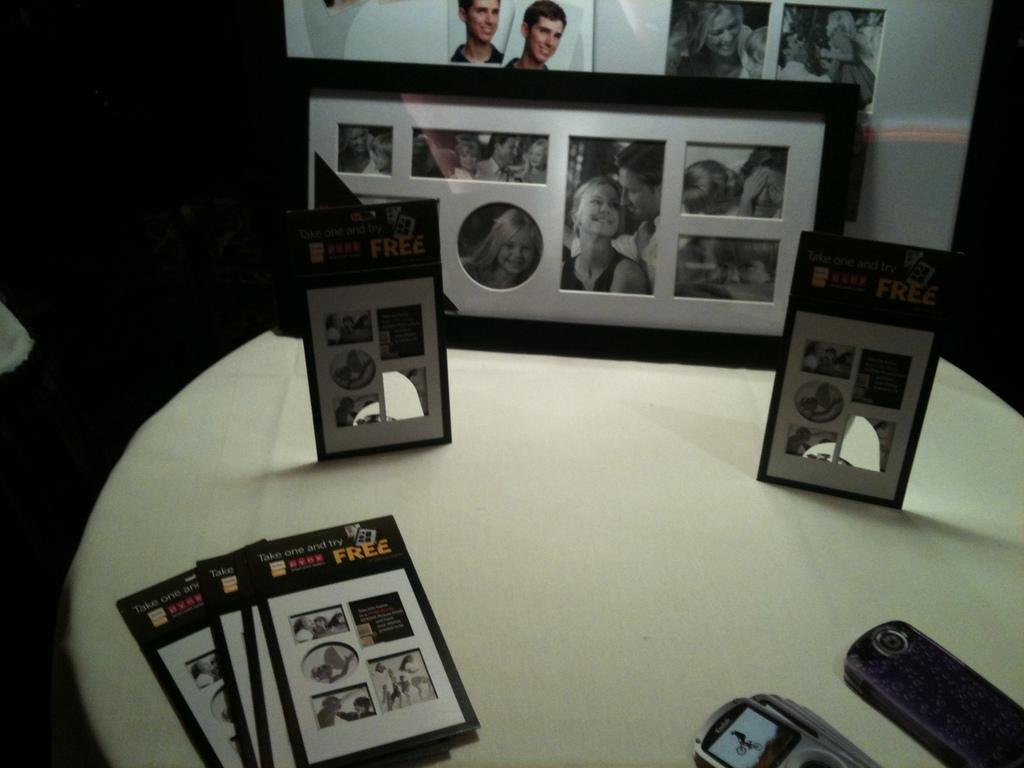<image>
Provide a brief description of the given image. A stack of cards says that people can take one and try for free. 